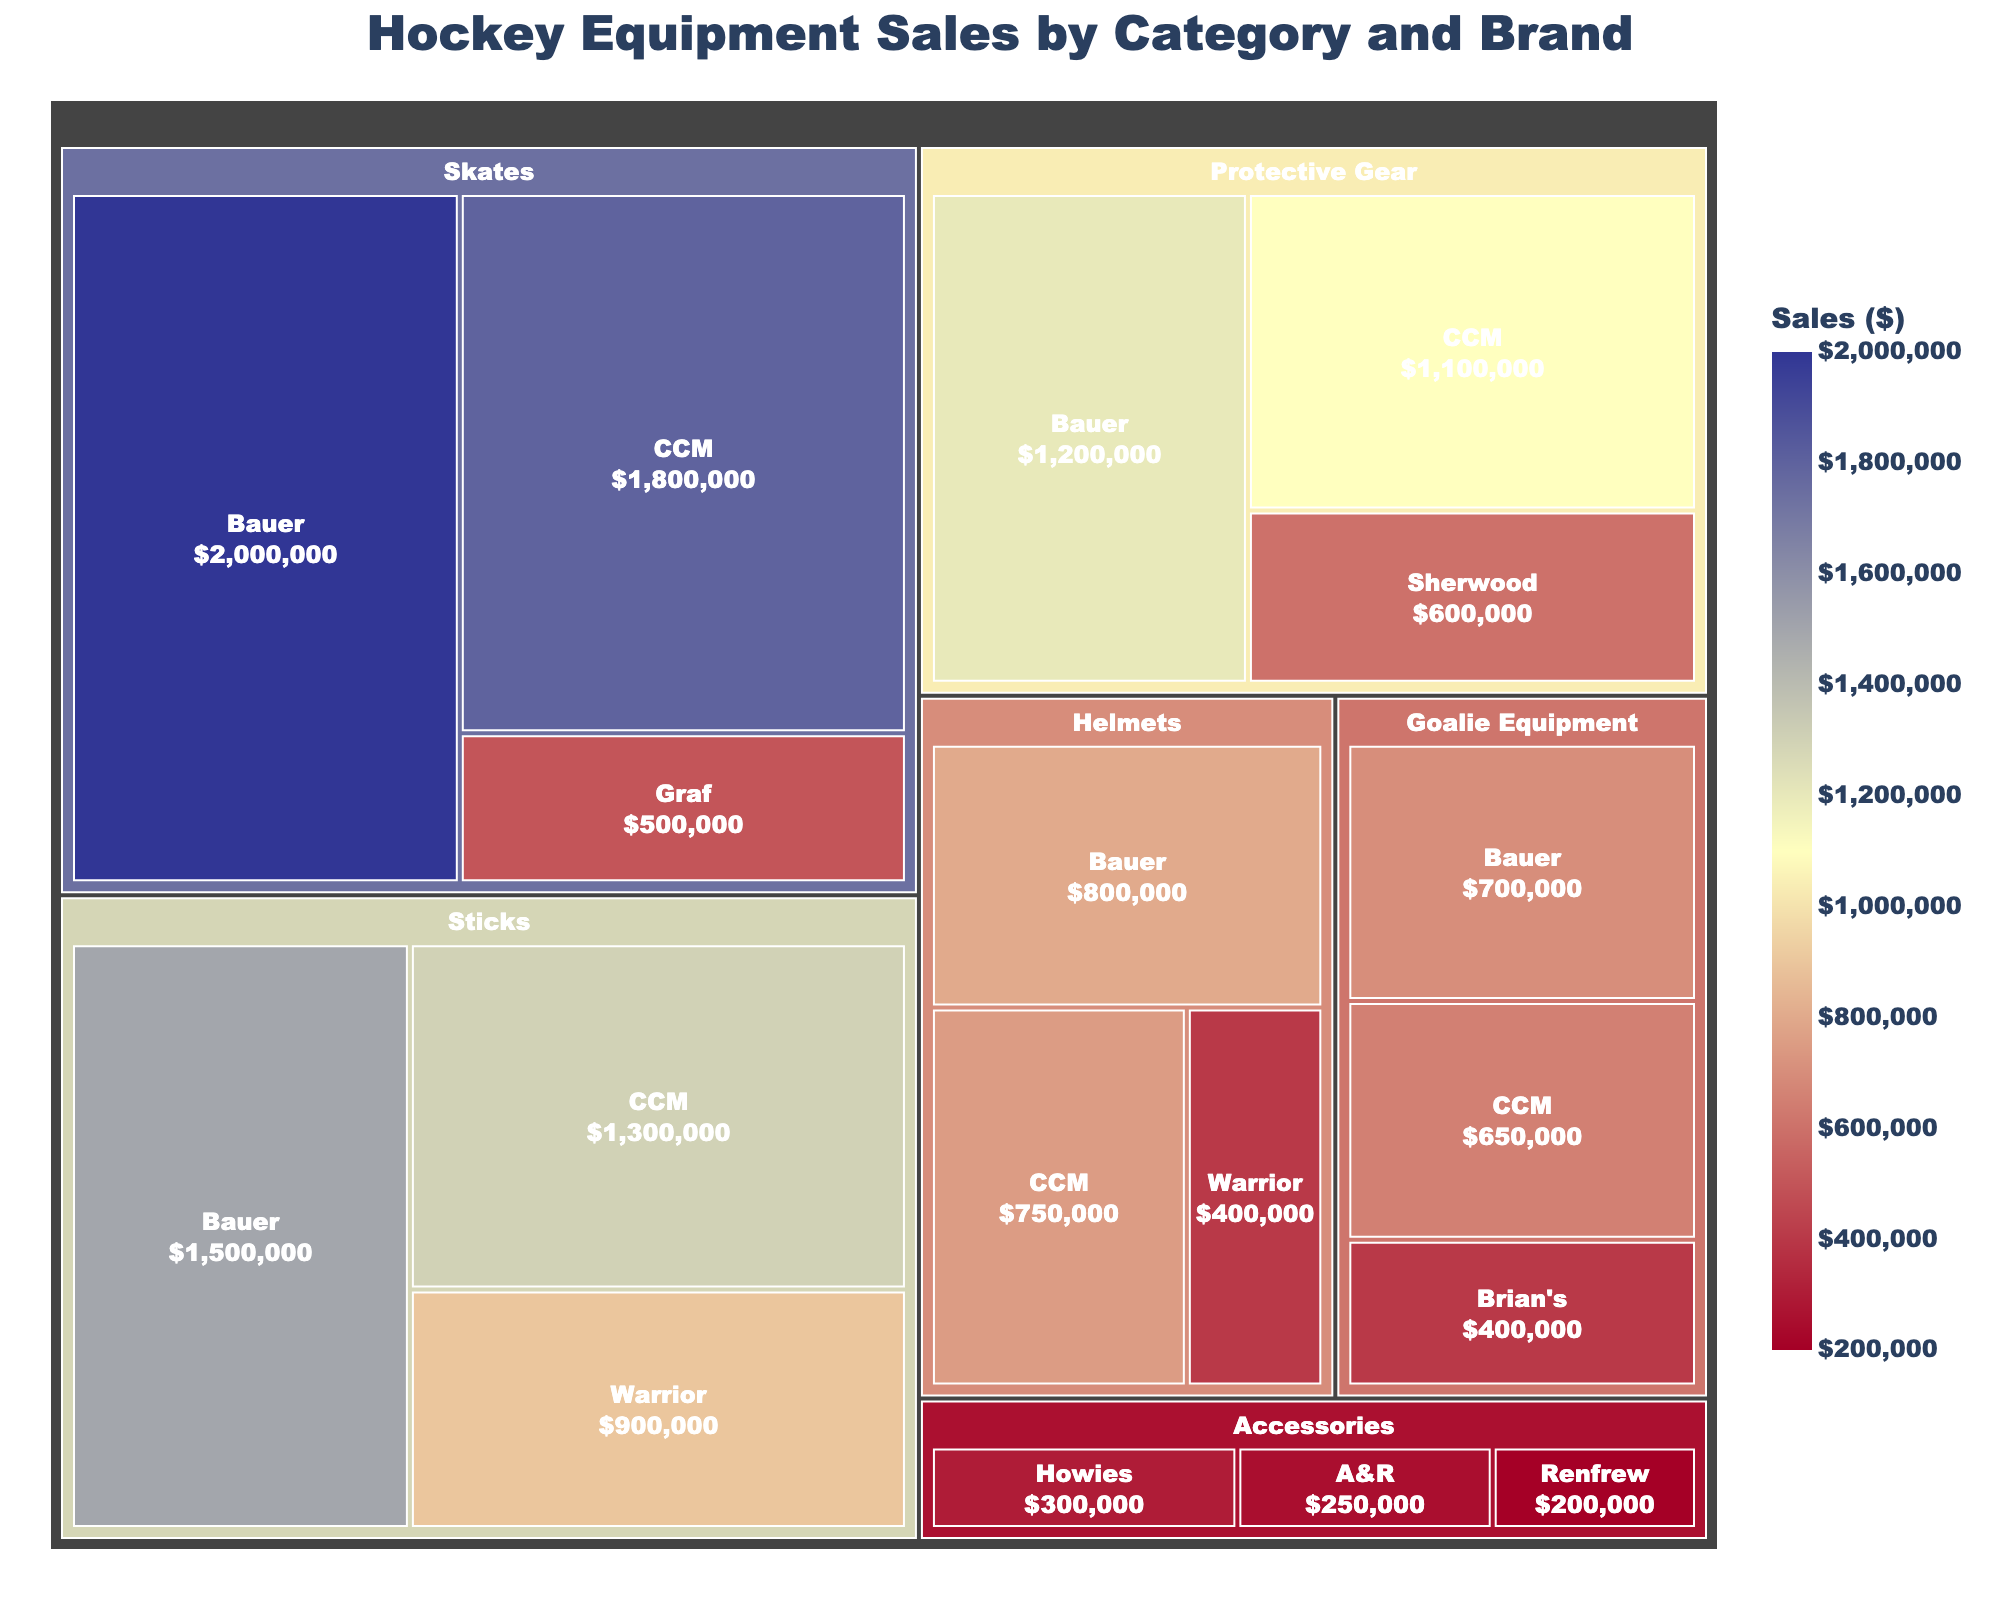Which category has the highest sales? By looking at the size of the blocks in the treemap, one can see that the "Skates" category has the largest area, indicating it has the highest sales.
Answer: Skates Which brand has the highest sales within the Sticks category? Navigate the treemap to find the "Sticks" category and then compare the areas of the brands within this category. Bauer has the largest block in the Sticks section.
Answer: Bauer What is the total sales value for the Accessories category? Summing up the sales for Accessories (Howies: $300,000, A&R: $250,000, Renfrew: $200,000) gives us the total.
Answer: $750,000 Which brand has the lowest sales in the Helmets category? Within the Helmets category, compare the areas of the brands. The brand with the smallest block is Warrior.
Answer: Warrior How do the sales of Bauer Skates compare to those of Bauer Sticks? Locate both the Bauer Skates and Bauer Sticks in the treemap. Bauer Skates has a larger block, indicating higher sales compared to Bauer Sticks.
Answer: Bauer Skates are higher What is the difference in sales between the Skates and Helmets categories? Calculate the total sales for each category (Skates: $4,500,000, Helmets: $1,950,000) and then find the difference by subtracting Helmets from Skates.
Answer: $2,550,000 Which category and brand combination has the smallest sales value? Locate the smallest block in the treemap. The smallest block corresponds to Renfrew under the Accessories category.
Answer: Accessories, Renfrew What is the combined sales value of Bauer and CCM across all categories? Sum the sales of Bauer ($5,300,000) and CCM ($4,400,000) across all categories.
Answer: $9,700,000 Which brand is the second highest selling in the Protective Gear category? Navigate to the Protective Gear category and rank the areas of the blocks. CCM has the second-largest block after Bauer.
Answer: CCM What percentage of total sales does the Goalie Equipment category represent? Sum all sales in the dataset to get the total, then divide Goalie Equipment sales by this total, and multiply by 100 for percentage. Total Sales: $13,350,000; Goalie Equipment: $1,750,000. Calculation: ($1,750,000 / $13,350,000) * 100
Answer: 13.1% 